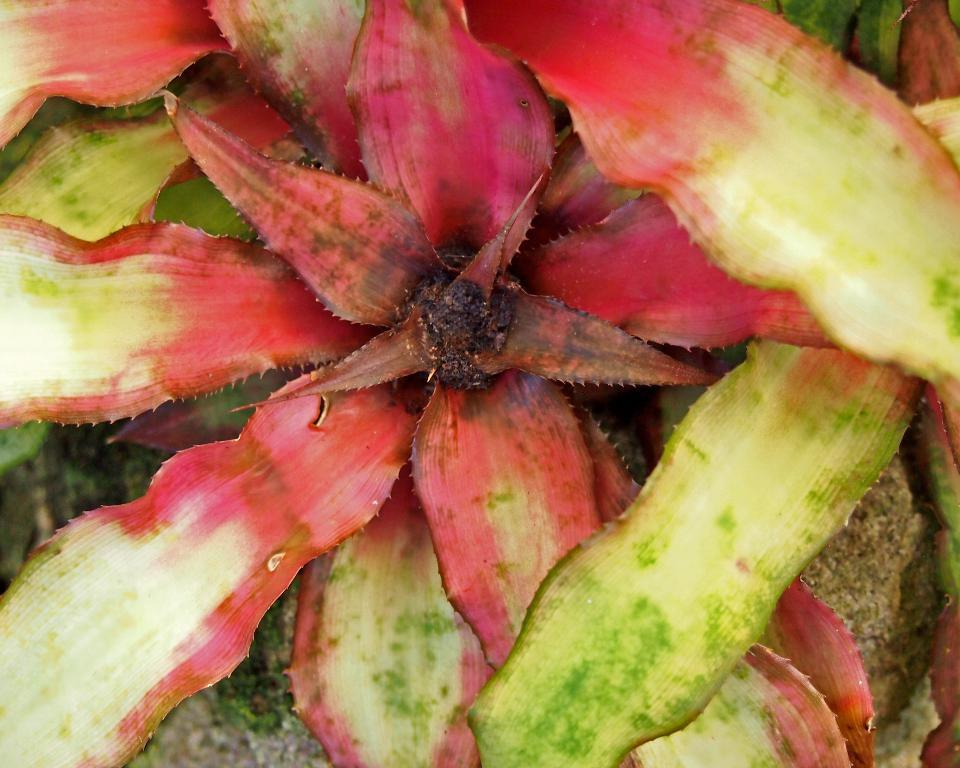What type of plant material is visible in the image? There are leaves of a plant in the image. Can you describe the appearance of the leaves? The leaves appear to be green and may have veins or other textures visible. What might be the purpose of these leaves on the plant? The leaves may be involved in photosynthesis, providing the plant with energy from sunlight. How many ants can be seen crawling on the leaves in the image? There are no ants visible in the image; it only shows leaves of a plant. 